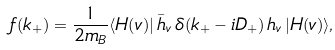<formula> <loc_0><loc_0><loc_500><loc_500>f ( k _ { + } ) = \frac { 1 } { 2 m _ { B } } \langle H ( v ) | \, \bar { h } _ { v } \, \delta ( k _ { + } - i D _ { + } ) \, h _ { v } \, | H ( v ) \rangle ,</formula> 